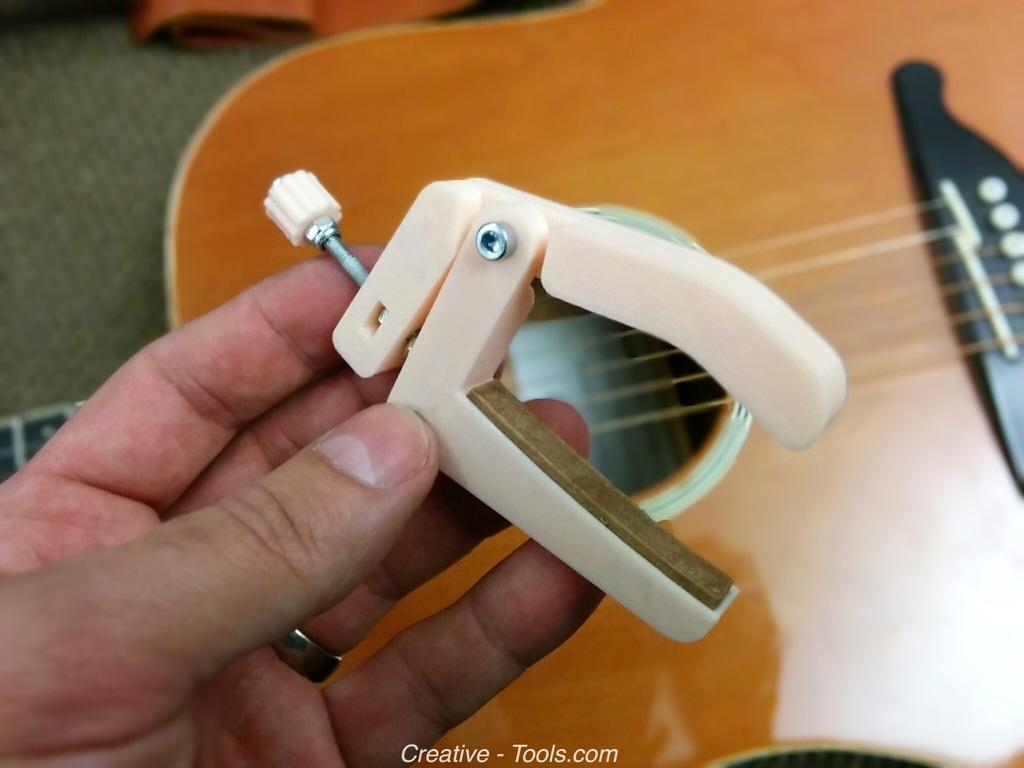What musical instrument is present in the image? There is a guitar in the image. What is the person in the image doing with the guitar? There is a hand holding a guitar tuner in the image, suggesting that the person is tuning the guitar. Is there a girl participating in a battle in the image? There is no girl or battle present in the image; it only features a guitar and a hand holding a guitar tuner. 